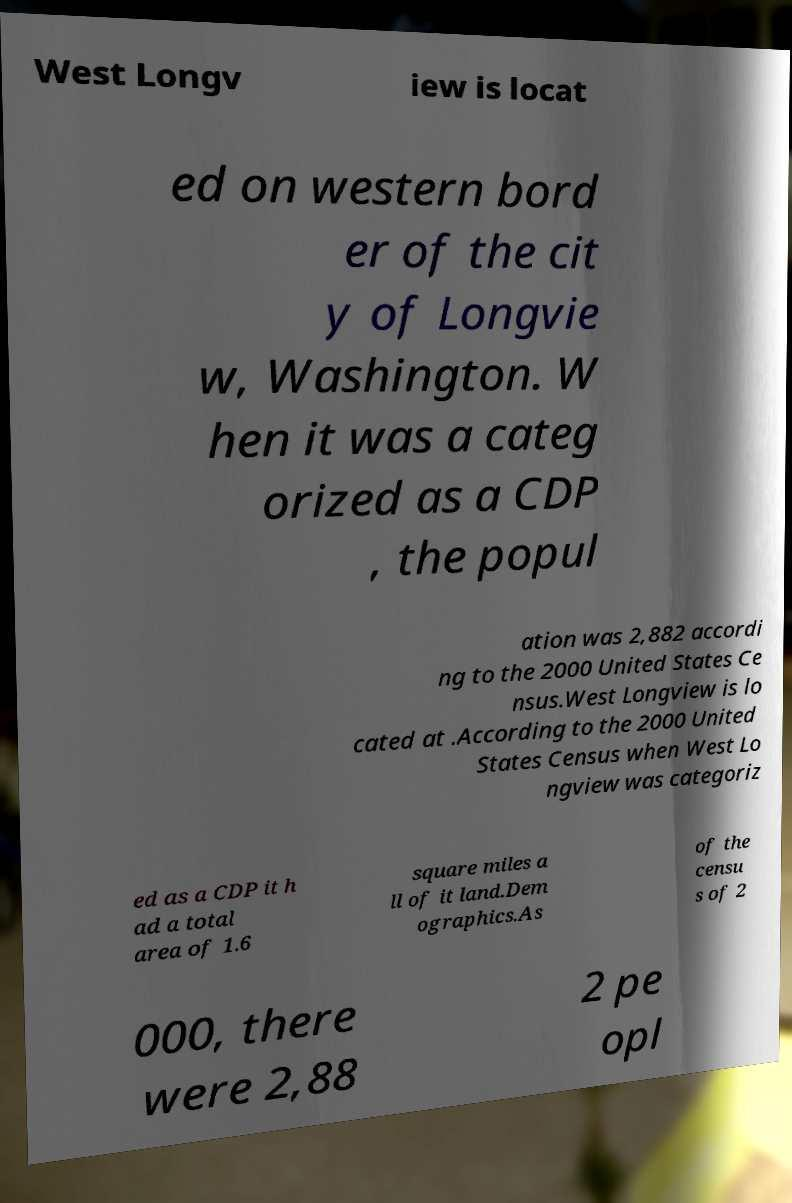Can you read and provide the text displayed in the image?This photo seems to have some interesting text. Can you extract and type it out for me? West Longv iew is locat ed on western bord er of the cit y of Longvie w, Washington. W hen it was a categ orized as a CDP , the popul ation was 2,882 accordi ng to the 2000 United States Ce nsus.West Longview is lo cated at .According to the 2000 United States Census when West Lo ngview was categoriz ed as a CDP it h ad a total area of 1.6 square miles a ll of it land.Dem ographics.As of the censu s of 2 000, there were 2,88 2 pe opl 